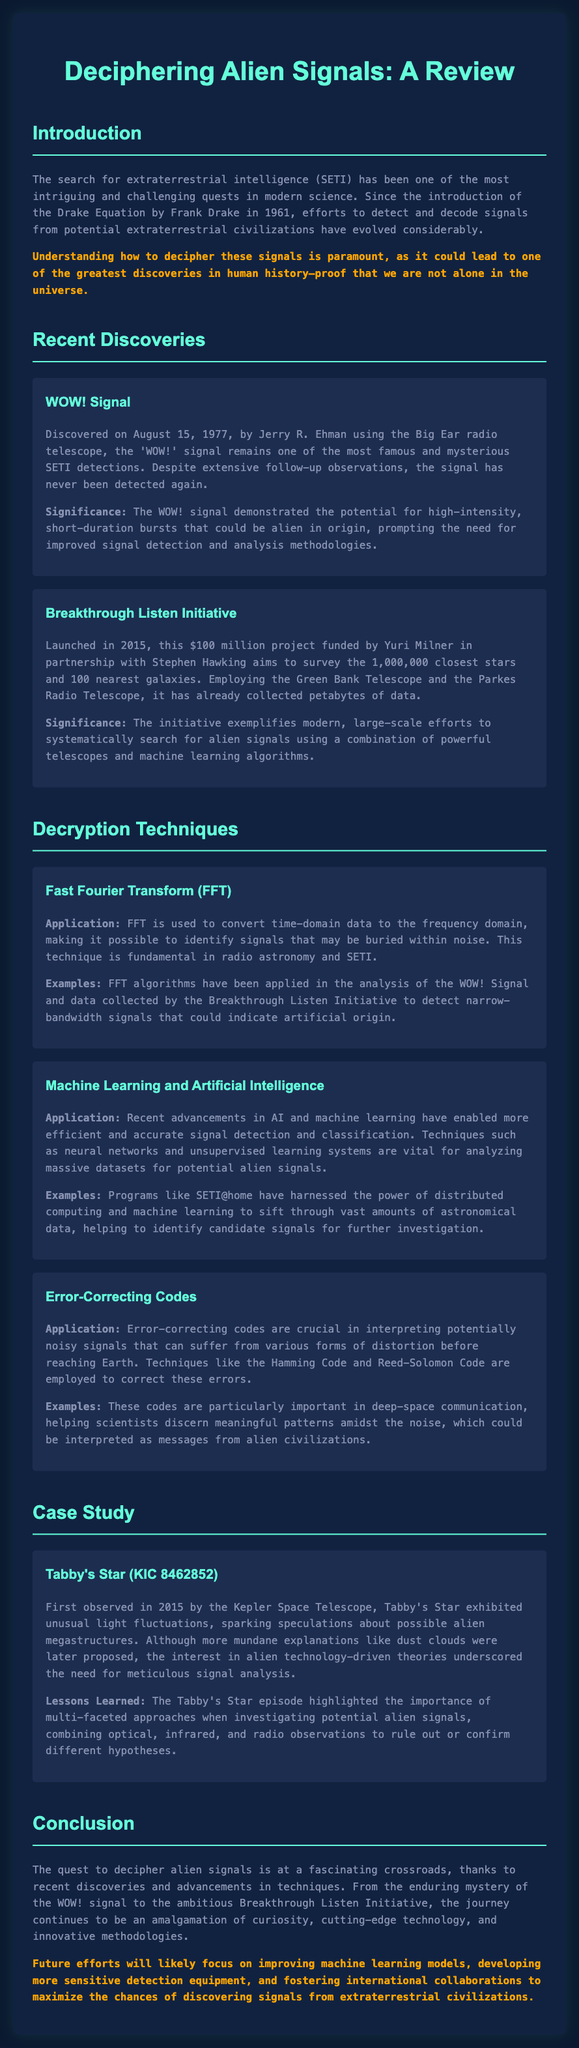What is the date of the WOW! signal discovery? The document states that the WOW! signal was discovered on August 15, 1977.
Answer: August 15, 1977 Who funded the Breakthrough Listen Initiative? The document mentions that the Breakthrough Listen Initiative was funded by Yuri Milner.
Answer: Yuri Milner What technique is used to convert time-domain data to the frequency domain? The document explains that Fast Fourier Transform (FFT) is used for this purpose.
Answer: Fast Fourier Transform (FFT) What is the primary application of error-correcting codes in signal decryption? The document states that error-correcting codes are crucial in interpreting potentially noisy signals.
Answer: Interpreting noisy signals Which star exhibited unusual light fluctuations? The document indicates that Tabby's Star (KIC 8462852) exhibited these fluctuations.
Answer: Tabby's Star (KIC 8462852) What significant lesson was learned from the Tabby's Star case study? The document highlights the importance of multi-faceted approaches in investigating potential alien signals.
Answer: Multi-faceted approaches What was the budget of the Breakthrough Listen Initiative? The document specifies that the Breakthrough Listen Initiative had a budget of $100 million.
Answer: $100 million What methodology was employed by programs like SETI@home? The document mentions that distributed computing and machine learning were used in these programs.
Answer: Distributed computing and machine learning 